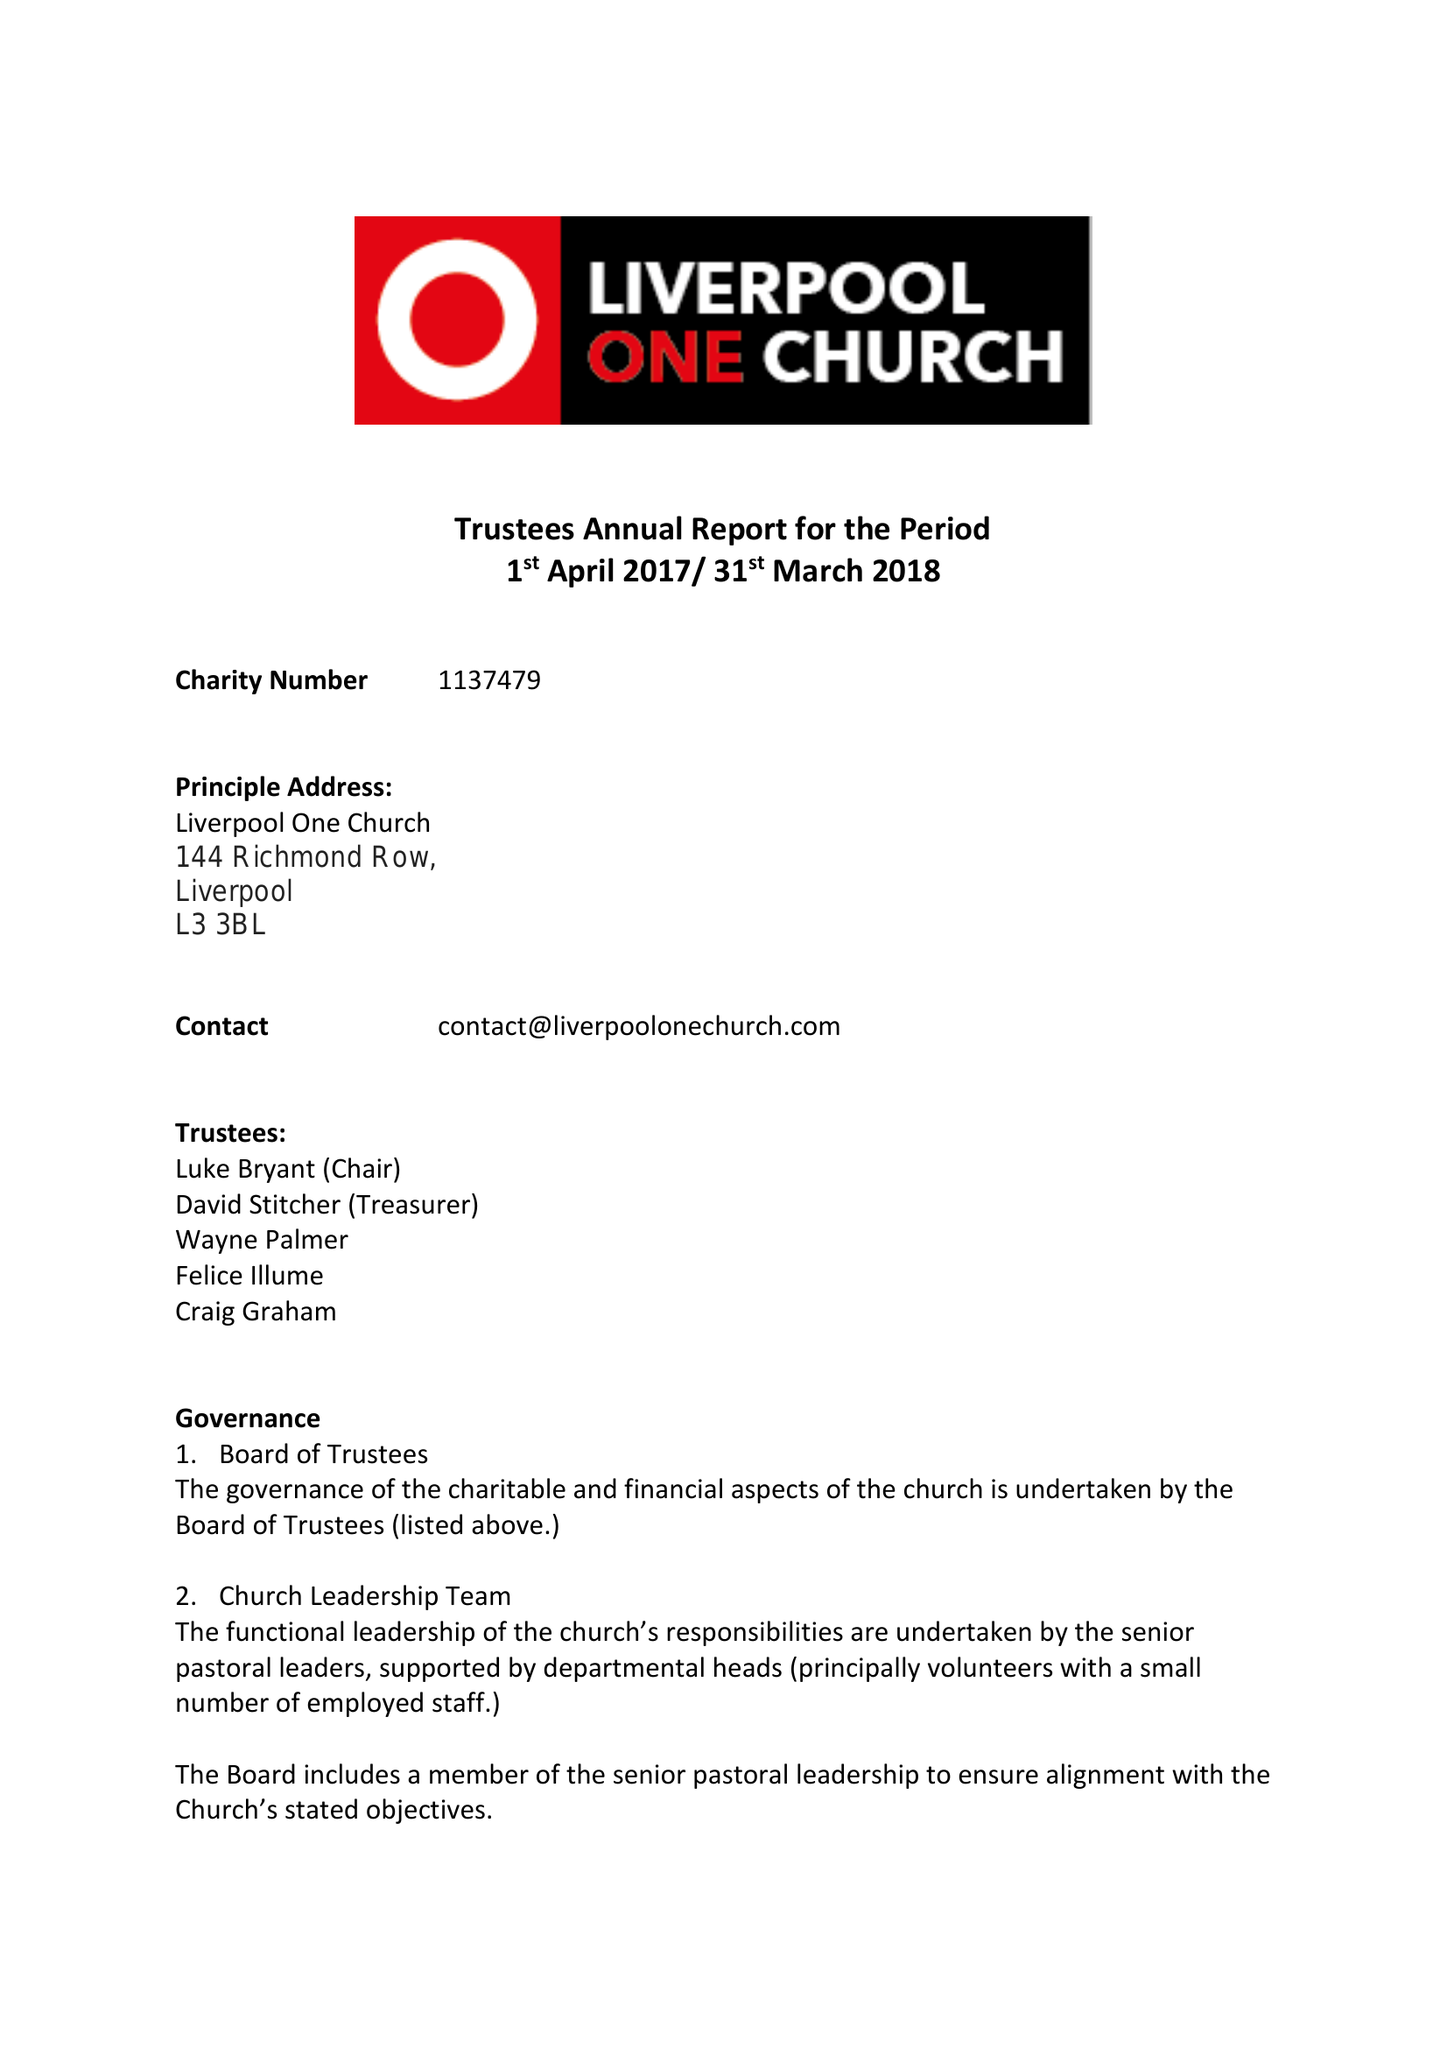What is the value for the address__street_line?
Answer the question using a single word or phrase. 144 RICHMOND ROW 